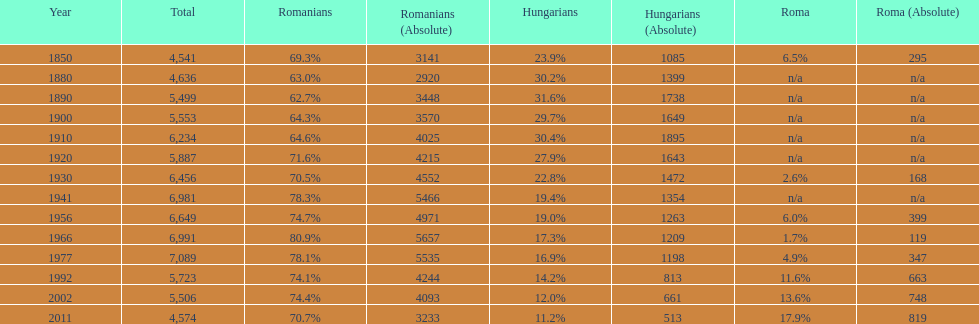What year had the highest total number? 1977. 